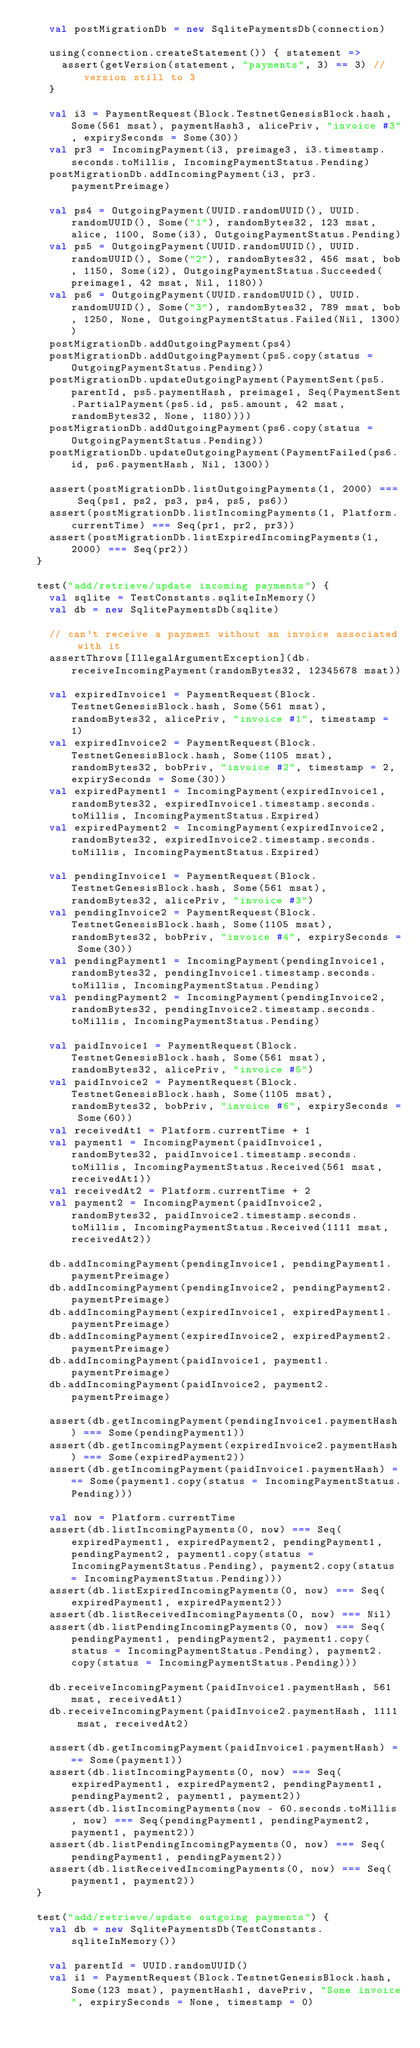Convert code to text. <code><loc_0><loc_0><loc_500><loc_500><_Scala_>    val postMigrationDb = new SqlitePaymentsDb(connection)

    using(connection.createStatement()) { statement =>
      assert(getVersion(statement, "payments", 3) == 3) // version still to 3
    }

    val i3 = PaymentRequest(Block.TestnetGenesisBlock.hash, Some(561 msat), paymentHash3, alicePriv, "invoice #3", expirySeconds = Some(30))
    val pr3 = IncomingPayment(i3, preimage3, i3.timestamp.seconds.toMillis, IncomingPaymentStatus.Pending)
    postMigrationDb.addIncomingPayment(i3, pr3.paymentPreimage)

    val ps4 = OutgoingPayment(UUID.randomUUID(), UUID.randomUUID(), Some("1"), randomBytes32, 123 msat, alice, 1100, Some(i3), OutgoingPaymentStatus.Pending)
    val ps5 = OutgoingPayment(UUID.randomUUID(), UUID.randomUUID(), Some("2"), randomBytes32, 456 msat, bob, 1150, Some(i2), OutgoingPaymentStatus.Succeeded(preimage1, 42 msat, Nil, 1180))
    val ps6 = OutgoingPayment(UUID.randomUUID(), UUID.randomUUID(), Some("3"), randomBytes32, 789 msat, bob, 1250, None, OutgoingPaymentStatus.Failed(Nil, 1300))
    postMigrationDb.addOutgoingPayment(ps4)
    postMigrationDb.addOutgoingPayment(ps5.copy(status = OutgoingPaymentStatus.Pending))
    postMigrationDb.updateOutgoingPayment(PaymentSent(ps5.parentId, ps5.paymentHash, preimage1, Seq(PaymentSent.PartialPayment(ps5.id, ps5.amount, 42 msat, randomBytes32, None, 1180))))
    postMigrationDb.addOutgoingPayment(ps6.copy(status = OutgoingPaymentStatus.Pending))
    postMigrationDb.updateOutgoingPayment(PaymentFailed(ps6.id, ps6.paymentHash, Nil, 1300))

    assert(postMigrationDb.listOutgoingPayments(1, 2000) === Seq(ps1, ps2, ps3, ps4, ps5, ps6))
    assert(postMigrationDb.listIncomingPayments(1, Platform.currentTime) === Seq(pr1, pr2, pr3))
    assert(postMigrationDb.listExpiredIncomingPayments(1, 2000) === Seq(pr2))
  }

  test("add/retrieve/update incoming payments") {
    val sqlite = TestConstants.sqliteInMemory()
    val db = new SqlitePaymentsDb(sqlite)

    // can't receive a payment without an invoice associated with it
    assertThrows[IllegalArgumentException](db.receiveIncomingPayment(randomBytes32, 12345678 msat))

    val expiredInvoice1 = PaymentRequest(Block.TestnetGenesisBlock.hash, Some(561 msat), randomBytes32, alicePriv, "invoice #1", timestamp = 1)
    val expiredInvoice2 = PaymentRequest(Block.TestnetGenesisBlock.hash, Some(1105 msat), randomBytes32, bobPriv, "invoice #2", timestamp = 2, expirySeconds = Some(30))
    val expiredPayment1 = IncomingPayment(expiredInvoice1, randomBytes32, expiredInvoice1.timestamp.seconds.toMillis, IncomingPaymentStatus.Expired)
    val expiredPayment2 = IncomingPayment(expiredInvoice2, randomBytes32, expiredInvoice2.timestamp.seconds.toMillis, IncomingPaymentStatus.Expired)

    val pendingInvoice1 = PaymentRequest(Block.TestnetGenesisBlock.hash, Some(561 msat), randomBytes32, alicePriv, "invoice #3")
    val pendingInvoice2 = PaymentRequest(Block.TestnetGenesisBlock.hash, Some(1105 msat), randomBytes32, bobPriv, "invoice #4", expirySeconds = Some(30))
    val pendingPayment1 = IncomingPayment(pendingInvoice1, randomBytes32, pendingInvoice1.timestamp.seconds.toMillis, IncomingPaymentStatus.Pending)
    val pendingPayment2 = IncomingPayment(pendingInvoice2, randomBytes32, pendingInvoice2.timestamp.seconds.toMillis, IncomingPaymentStatus.Pending)

    val paidInvoice1 = PaymentRequest(Block.TestnetGenesisBlock.hash, Some(561 msat), randomBytes32, alicePriv, "invoice #5")
    val paidInvoice2 = PaymentRequest(Block.TestnetGenesisBlock.hash, Some(1105 msat), randomBytes32, bobPriv, "invoice #6", expirySeconds = Some(60))
    val receivedAt1 = Platform.currentTime + 1
    val payment1 = IncomingPayment(paidInvoice1, randomBytes32, paidInvoice1.timestamp.seconds.toMillis, IncomingPaymentStatus.Received(561 msat, receivedAt1))
    val receivedAt2 = Platform.currentTime + 2
    val payment2 = IncomingPayment(paidInvoice2, randomBytes32, paidInvoice2.timestamp.seconds.toMillis, IncomingPaymentStatus.Received(1111 msat, receivedAt2))

    db.addIncomingPayment(pendingInvoice1, pendingPayment1.paymentPreimage)
    db.addIncomingPayment(pendingInvoice2, pendingPayment2.paymentPreimage)
    db.addIncomingPayment(expiredInvoice1, expiredPayment1.paymentPreimage)
    db.addIncomingPayment(expiredInvoice2, expiredPayment2.paymentPreimage)
    db.addIncomingPayment(paidInvoice1, payment1.paymentPreimage)
    db.addIncomingPayment(paidInvoice2, payment2.paymentPreimage)

    assert(db.getIncomingPayment(pendingInvoice1.paymentHash) === Some(pendingPayment1))
    assert(db.getIncomingPayment(expiredInvoice2.paymentHash) === Some(expiredPayment2))
    assert(db.getIncomingPayment(paidInvoice1.paymentHash) === Some(payment1.copy(status = IncomingPaymentStatus.Pending)))

    val now = Platform.currentTime
    assert(db.listIncomingPayments(0, now) === Seq(expiredPayment1, expiredPayment2, pendingPayment1, pendingPayment2, payment1.copy(status = IncomingPaymentStatus.Pending), payment2.copy(status = IncomingPaymentStatus.Pending)))
    assert(db.listExpiredIncomingPayments(0, now) === Seq(expiredPayment1, expiredPayment2))
    assert(db.listReceivedIncomingPayments(0, now) === Nil)
    assert(db.listPendingIncomingPayments(0, now) === Seq(pendingPayment1, pendingPayment2, payment1.copy(status = IncomingPaymentStatus.Pending), payment2.copy(status = IncomingPaymentStatus.Pending)))

    db.receiveIncomingPayment(paidInvoice1.paymentHash, 561 msat, receivedAt1)
    db.receiveIncomingPayment(paidInvoice2.paymentHash, 1111 msat, receivedAt2)

    assert(db.getIncomingPayment(paidInvoice1.paymentHash) === Some(payment1))
    assert(db.listIncomingPayments(0, now) === Seq(expiredPayment1, expiredPayment2, pendingPayment1, pendingPayment2, payment1, payment2))
    assert(db.listIncomingPayments(now - 60.seconds.toMillis, now) === Seq(pendingPayment1, pendingPayment2, payment1, payment2))
    assert(db.listPendingIncomingPayments(0, now) === Seq(pendingPayment1, pendingPayment2))
    assert(db.listReceivedIncomingPayments(0, now) === Seq(payment1, payment2))
  }

  test("add/retrieve/update outgoing payments") {
    val db = new SqlitePaymentsDb(TestConstants.sqliteInMemory())

    val parentId = UUID.randomUUID()
    val i1 = PaymentRequest(Block.TestnetGenesisBlock.hash, Some(123 msat), paymentHash1, davePriv, "Some invoice", expirySeconds = None, timestamp = 0)</code> 